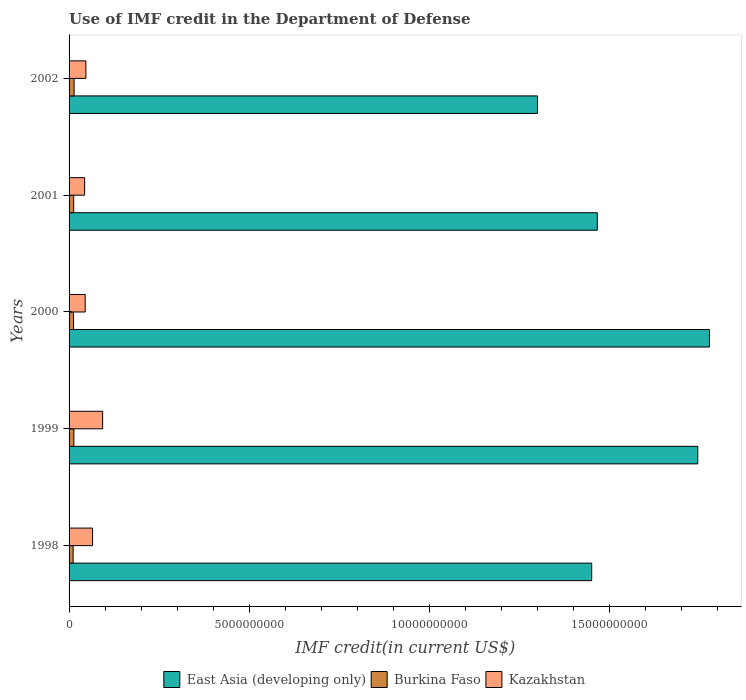How many different coloured bars are there?
Keep it short and to the point. 3. How many groups of bars are there?
Your answer should be very brief. 5. How many bars are there on the 2nd tick from the top?
Your answer should be very brief. 3. How many bars are there on the 5th tick from the bottom?
Make the answer very short. 3. What is the label of the 1st group of bars from the top?
Provide a succinct answer. 2002. What is the IMF credit in the Department of Defense in East Asia (developing only) in 1999?
Your response must be concise. 1.75e+1. Across all years, what is the maximum IMF credit in the Department of Defense in East Asia (developing only)?
Your answer should be compact. 1.78e+1. Across all years, what is the minimum IMF credit in the Department of Defense in Kazakhstan?
Ensure brevity in your answer.  4.32e+08. In which year was the IMF credit in the Department of Defense in East Asia (developing only) maximum?
Provide a short and direct response. 2000. In which year was the IMF credit in the Department of Defense in Kazakhstan minimum?
Your answer should be compact. 2001. What is the total IMF credit in the Department of Defense in East Asia (developing only) in the graph?
Your answer should be very brief. 7.74e+1. What is the difference between the IMF credit in the Department of Defense in Burkina Faso in 1999 and that in 2001?
Offer a very short reply. 5.27e+06. What is the difference between the IMF credit in the Department of Defense in East Asia (developing only) in 1999 and the IMF credit in the Department of Defense in Kazakhstan in 2001?
Offer a very short reply. 1.70e+1. What is the average IMF credit in the Department of Defense in Kazakhstan per year?
Make the answer very short. 5.86e+08. In the year 2002, what is the difference between the IMF credit in the Department of Defense in Burkina Faso and IMF credit in the Department of Defense in East Asia (developing only)?
Provide a succinct answer. -1.29e+1. What is the ratio of the IMF credit in the Department of Defense in East Asia (developing only) in 2001 to that in 2002?
Give a very brief answer. 1.13. Is the IMF credit in the Department of Defense in Burkina Faso in 1998 less than that in 2002?
Offer a very short reply. Yes. Is the difference between the IMF credit in the Department of Defense in Burkina Faso in 1998 and 1999 greater than the difference between the IMF credit in the Department of Defense in East Asia (developing only) in 1998 and 1999?
Give a very brief answer. Yes. What is the difference between the highest and the second highest IMF credit in the Department of Defense in East Asia (developing only)?
Ensure brevity in your answer.  3.25e+08. What is the difference between the highest and the lowest IMF credit in the Department of Defense in Burkina Faso?
Offer a very short reply. 2.72e+07. What does the 2nd bar from the top in 2002 represents?
Offer a very short reply. Burkina Faso. What does the 1st bar from the bottom in 2000 represents?
Offer a terse response. East Asia (developing only). Is it the case that in every year, the sum of the IMF credit in the Department of Defense in East Asia (developing only) and IMF credit in the Department of Defense in Burkina Faso is greater than the IMF credit in the Department of Defense in Kazakhstan?
Make the answer very short. Yes. Are all the bars in the graph horizontal?
Offer a terse response. Yes. How many years are there in the graph?
Offer a very short reply. 5. Are the values on the major ticks of X-axis written in scientific E-notation?
Provide a succinct answer. No. Does the graph contain any zero values?
Your response must be concise. No. Where does the legend appear in the graph?
Your response must be concise. Bottom center. What is the title of the graph?
Your answer should be very brief. Use of IMF credit in the Department of Defense. What is the label or title of the X-axis?
Ensure brevity in your answer.  IMF credit(in current US$). What is the label or title of the Y-axis?
Keep it short and to the point. Years. What is the IMF credit(in current US$) in East Asia (developing only) in 1998?
Your answer should be very brief. 1.45e+1. What is the IMF credit(in current US$) of Burkina Faso in 1998?
Your answer should be very brief. 1.12e+08. What is the IMF credit(in current US$) in Kazakhstan in 1998?
Offer a terse response. 6.53e+08. What is the IMF credit(in current US$) of East Asia (developing only) in 1999?
Give a very brief answer. 1.75e+1. What is the IMF credit(in current US$) of Burkina Faso in 1999?
Provide a short and direct response. 1.34e+08. What is the IMF credit(in current US$) of Kazakhstan in 1999?
Ensure brevity in your answer.  9.32e+08. What is the IMF credit(in current US$) in East Asia (developing only) in 2000?
Your answer should be compact. 1.78e+1. What is the IMF credit(in current US$) in Burkina Faso in 2000?
Offer a very short reply. 1.24e+08. What is the IMF credit(in current US$) of Kazakhstan in 2000?
Provide a succinct answer. 4.48e+08. What is the IMF credit(in current US$) of East Asia (developing only) in 2001?
Your answer should be compact. 1.47e+1. What is the IMF credit(in current US$) in Burkina Faso in 2001?
Provide a succinct answer. 1.28e+08. What is the IMF credit(in current US$) of Kazakhstan in 2001?
Your response must be concise. 4.32e+08. What is the IMF credit(in current US$) of East Asia (developing only) in 2002?
Offer a very short reply. 1.30e+1. What is the IMF credit(in current US$) in Burkina Faso in 2002?
Provide a succinct answer. 1.39e+08. What is the IMF credit(in current US$) in Kazakhstan in 2002?
Make the answer very short. 4.67e+08. Across all years, what is the maximum IMF credit(in current US$) in East Asia (developing only)?
Ensure brevity in your answer.  1.78e+1. Across all years, what is the maximum IMF credit(in current US$) of Burkina Faso?
Your answer should be compact. 1.39e+08. Across all years, what is the maximum IMF credit(in current US$) in Kazakhstan?
Make the answer very short. 9.32e+08. Across all years, what is the minimum IMF credit(in current US$) in East Asia (developing only)?
Keep it short and to the point. 1.30e+1. Across all years, what is the minimum IMF credit(in current US$) in Burkina Faso?
Your answer should be very brief. 1.12e+08. Across all years, what is the minimum IMF credit(in current US$) in Kazakhstan?
Offer a terse response. 4.32e+08. What is the total IMF credit(in current US$) in East Asia (developing only) in the graph?
Provide a short and direct response. 7.74e+1. What is the total IMF credit(in current US$) of Burkina Faso in the graph?
Offer a very short reply. 6.38e+08. What is the total IMF credit(in current US$) of Kazakhstan in the graph?
Provide a short and direct response. 2.93e+09. What is the difference between the IMF credit(in current US$) in East Asia (developing only) in 1998 and that in 1999?
Your answer should be very brief. -2.95e+09. What is the difference between the IMF credit(in current US$) in Burkina Faso in 1998 and that in 1999?
Give a very brief answer. -2.15e+07. What is the difference between the IMF credit(in current US$) in Kazakhstan in 1998 and that in 1999?
Keep it short and to the point. -2.79e+08. What is the difference between the IMF credit(in current US$) of East Asia (developing only) in 1998 and that in 2000?
Offer a very short reply. -3.27e+09. What is the difference between the IMF credit(in current US$) in Burkina Faso in 1998 and that in 2000?
Give a very brief answer. -1.23e+07. What is the difference between the IMF credit(in current US$) of Kazakhstan in 1998 and that in 2000?
Provide a succinct answer. 2.05e+08. What is the difference between the IMF credit(in current US$) in East Asia (developing only) in 1998 and that in 2001?
Offer a terse response. -1.56e+08. What is the difference between the IMF credit(in current US$) in Burkina Faso in 1998 and that in 2001?
Provide a short and direct response. -1.62e+07. What is the difference between the IMF credit(in current US$) of Kazakhstan in 1998 and that in 2001?
Make the answer very short. 2.21e+08. What is the difference between the IMF credit(in current US$) in East Asia (developing only) in 1998 and that in 2002?
Provide a succinct answer. 1.50e+09. What is the difference between the IMF credit(in current US$) of Burkina Faso in 1998 and that in 2002?
Keep it short and to the point. -2.72e+07. What is the difference between the IMF credit(in current US$) of Kazakhstan in 1998 and that in 2002?
Keep it short and to the point. 1.86e+08. What is the difference between the IMF credit(in current US$) of East Asia (developing only) in 1999 and that in 2000?
Ensure brevity in your answer.  -3.25e+08. What is the difference between the IMF credit(in current US$) of Burkina Faso in 1999 and that in 2000?
Keep it short and to the point. 9.20e+06. What is the difference between the IMF credit(in current US$) of Kazakhstan in 1999 and that in 2000?
Offer a very short reply. 4.84e+08. What is the difference between the IMF credit(in current US$) in East Asia (developing only) in 1999 and that in 2001?
Provide a short and direct response. 2.79e+09. What is the difference between the IMF credit(in current US$) of Burkina Faso in 1999 and that in 2001?
Provide a succinct answer. 5.27e+06. What is the difference between the IMF credit(in current US$) in Kazakhstan in 1999 and that in 2001?
Provide a succinct answer. 5.00e+08. What is the difference between the IMF credit(in current US$) in East Asia (developing only) in 1999 and that in 2002?
Provide a succinct answer. 4.45e+09. What is the difference between the IMF credit(in current US$) of Burkina Faso in 1999 and that in 2002?
Offer a very short reply. -5.69e+06. What is the difference between the IMF credit(in current US$) in Kazakhstan in 1999 and that in 2002?
Your answer should be compact. 4.64e+08. What is the difference between the IMF credit(in current US$) of East Asia (developing only) in 2000 and that in 2001?
Ensure brevity in your answer.  3.11e+09. What is the difference between the IMF credit(in current US$) of Burkina Faso in 2000 and that in 2001?
Your response must be concise. -3.93e+06. What is the difference between the IMF credit(in current US$) in Kazakhstan in 2000 and that in 2001?
Provide a short and direct response. 1.59e+07. What is the difference between the IMF credit(in current US$) in East Asia (developing only) in 2000 and that in 2002?
Ensure brevity in your answer.  4.77e+09. What is the difference between the IMF credit(in current US$) of Burkina Faso in 2000 and that in 2002?
Ensure brevity in your answer.  -1.49e+07. What is the difference between the IMF credit(in current US$) in Kazakhstan in 2000 and that in 2002?
Ensure brevity in your answer.  -1.95e+07. What is the difference between the IMF credit(in current US$) of East Asia (developing only) in 2001 and that in 2002?
Make the answer very short. 1.66e+09. What is the difference between the IMF credit(in current US$) of Burkina Faso in 2001 and that in 2002?
Your response must be concise. -1.10e+07. What is the difference between the IMF credit(in current US$) in Kazakhstan in 2001 and that in 2002?
Offer a terse response. -3.53e+07. What is the difference between the IMF credit(in current US$) in East Asia (developing only) in 1998 and the IMF credit(in current US$) in Burkina Faso in 1999?
Your response must be concise. 1.44e+1. What is the difference between the IMF credit(in current US$) in East Asia (developing only) in 1998 and the IMF credit(in current US$) in Kazakhstan in 1999?
Your answer should be very brief. 1.36e+1. What is the difference between the IMF credit(in current US$) of Burkina Faso in 1998 and the IMF credit(in current US$) of Kazakhstan in 1999?
Give a very brief answer. -8.20e+08. What is the difference between the IMF credit(in current US$) of East Asia (developing only) in 1998 and the IMF credit(in current US$) of Burkina Faso in 2000?
Your answer should be very brief. 1.44e+1. What is the difference between the IMF credit(in current US$) of East Asia (developing only) in 1998 and the IMF credit(in current US$) of Kazakhstan in 2000?
Your answer should be compact. 1.41e+1. What is the difference between the IMF credit(in current US$) of Burkina Faso in 1998 and the IMF credit(in current US$) of Kazakhstan in 2000?
Ensure brevity in your answer.  -3.36e+08. What is the difference between the IMF credit(in current US$) in East Asia (developing only) in 1998 and the IMF credit(in current US$) in Burkina Faso in 2001?
Provide a succinct answer. 1.44e+1. What is the difference between the IMF credit(in current US$) of East Asia (developing only) in 1998 and the IMF credit(in current US$) of Kazakhstan in 2001?
Keep it short and to the point. 1.41e+1. What is the difference between the IMF credit(in current US$) of Burkina Faso in 1998 and the IMF credit(in current US$) of Kazakhstan in 2001?
Keep it short and to the point. -3.20e+08. What is the difference between the IMF credit(in current US$) of East Asia (developing only) in 1998 and the IMF credit(in current US$) of Burkina Faso in 2002?
Make the answer very short. 1.44e+1. What is the difference between the IMF credit(in current US$) in East Asia (developing only) in 1998 and the IMF credit(in current US$) in Kazakhstan in 2002?
Make the answer very short. 1.40e+1. What is the difference between the IMF credit(in current US$) of Burkina Faso in 1998 and the IMF credit(in current US$) of Kazakhstan in 2002?
Provide a succinct answer. -3.55e+08. What is the difference between the IMF credit(in current US$) in East Asia (developing only) in 1999 and the IMF credit(in current US$) in Burkina Faso in 2000?
Offer a very short reply. 1.73e+1. What is the difference between the IMF credit(in current US$) in East Asia (developing only) in 1999 and the IMF credit(in current US$) in Kazakhstan in 2000?
Keep it short and to the point. 1.70e+1. What is the difference between the IMF credit(in current US$) of Burkina Faso in 1999 and the IMF credit(in current US$) of Kazakhstan in 2000?
Ensure brevity in your answer.  -3.14e+08. What is the difference between the IMF credit(in current US$) of East Asia (developing only) in 1999 and the IMF credit(in current US$) of Burkina Faso in 2001?
Your response must be concise. 1.73e+1. What is the difference between the IMF credit(in current US$) in East Asia (developing only) in 1999 and the IMF credit(in current US$) in Kazakhstan in 2001?
Your answer should be very brief. 1.70e+1. What is the difference between the IMF credit(in current US$) in Burkina Faso in 1999 and the IMF credit(in current US$) in Kazakhstan in 2001?
Make the answer very short. -2.98e+08. What is the difference between the IMF credit(in current US$) in East Asia (developing only) in 1999 and the IMF credit(in current US$) in Burkina Faso in 2002?
Your answer should be very brief. 1.73e+1. What is the difference between the IMF credit(in current US$) in East Asia (developing only) in 1999 and the IMF credit(in current US$) in Kazakhstan in 2002?
Keep it short and to the point. 1.70e+1. What is the difference between the IMF credit(in current US$) of Burkina Faso in 1999 and the IMF credit(in current US$) of Kazakhstan in 2002?
Your answer should be compact. -3.34e+08. What is the difference between the IMF credit(in current US$) in East Asia (developing only) in 2000 and the IMF credit(in current US$) in Burkina Faso in 2001?
Provide a short and direct response. 1.77e+1. What is the difference between the IMF credit(in current US$) of East Asia (developing only) in 2000 and the IMF credit(in current US$) of Kazakhstan in 2001?
Provide a succinct answer. 1.73e+1. What is the difference between the IMF credit(in current US$) in Burkina Faso in 2000 and the IMF credit(in current US$) in Kazakhstan in 2001?
Provide a succinct answer. -3.07e+08. What is the difference between the IMF credit(in current US$) in East Asia (developing only) in 2000 and the IMF credit(in current US$) in Burkina Faso in 2002?
Ensure brevity in your answer.  1.76e+1. What is the difference between the IMF credit(in current US$) of East Asia (developing only) in 2000 and the IMF credit(in current US$) of Kazakhstan in 2002?
Give a very brief answer. 1.73e+1. What is the difference between the IMF credit(in current US$) in Burkina Faso in 2000 and the IMF credit(in current US$) in Kazakhstan in 2002?
Provide a succinct answer. -3.43e+08. What is the difference between the IMF credit(in current US$) of East Asia (developing only) in 2001 and the IMF credit(in current US$) of Burkina Faso in 2002?
Your response must be concise. 1.45e+1. What is the difference between the IMF credit(in current US$) in East Asia (developing only) in 2001 and the IMF credit(in current US$) in Kazakhstan in 2002?
Ensure brevity in your answer.  1.42e+1. What is the difference between the IMF credit(in current US$) in Burkina Faso in 2001 and the IMF credit(in current US$) in Kazakhstan in 2002?
Give a very brief answer. -3.39e+08. What is the average IMF credit(in current US$) in East Asia (developing only) per year?
Ensure brevity in your answer.  1.55e+1. What is the average IMF credit(in current US$) of Burkina Faso per year?
Your response must be concise. 1.28e+08. What is the average IMF credit(in current US$) of Kazakhstan per year?
Provide a succinct answer. 5.86e+08. In the year 1998, what is the difference between the IMF credit(in current US$) in East Asia (developing only) and IMF credit(in current US$) in Burkina Faso?
Keep it short and to the point. 1.44e+1. In the year 1998, what is the difference between the IMF credit(in current US$) of East Asia (developing only) and IMF credit(in current US$) of Kazakhstan?
Make the answer very short. 1.39e+1. In the year 1998, what is the difference between the IMF credit(in current US$) of Burkina Faso and IMF credit(in current US$) of Kazakhstan?
Offer a very short reply. -5.41e+08. In the year 1999, what is the difference between the IMF credit(in current US$) of East Asia (developing only) and IMF credit(in current US$) of Burkina Faso?
Keep it short and to the point. 1.73e+1. In the year 1999, what is the difference between the IMF credit(in current US$) of East Asia (developing only) and IMF credit(in current US$) of Kazakhstan?
Provide a short and direct response. 1.65e+1. In the year 1999, what is the difference between the IMF credit(in current US$) in Burkina Faso and IMF credit(in current US$) in Kazakhstan?
Your response must be concise. -7.98e+08. In the year 2000, what is the difference between the IMF credit(in current US$) of East Asia (developing only) and IMF credit(in current US$) of Burkina Faso?
Offer a very short reply. 1.77e+1. In the year 2000, what is the difference between the IMF credit(in current US$) of East Asia (developing only) and IMF credit(in current US$) of Kazakhstan?
Provide a succinct answer. 1.73e+1. In the year 2000, what is the difference between the IMF credit(in current US$) in Burkina Faso and IMF credit(in current US$) in Kazakhstan?
Offer a terse response. -3.23e+08. In the year 2001, what is the difference between the IMF credit(in current US$) of East Asia (developing only) and IMF credit(in current US$) of Burkina Faso?
Provide a succinct answer. 1.45e+1. In the year 2001, what is the difference between the IMF credit(in current US$) of East Asia (developing only) and IMF credit(in current US$) of Kazakhstan?
Your response must be concise. 1.42e+1. In the year 2001, what is the difference between the IMF credit(in current US$) in Burkina Faso and IMF credit(in current US$) in Kazakhstan?
Make the answer very short. -3.04e+08. In the year 2002, what is the difference between the IMF credit(in current US$) of East Asia (developing only) and IMF credit(in current US$) of Burkina Faso?
Your response must be concise. 1.29e+1. In the year 2002, what is the difference between the IMF credit(in current US$) of East Asia (developing only) and IMF credit(in current US$) of Kazakhstan?
Ensure brevity in your answer.  1.25e+1. In the year 2002, what is the difference between the IMF credit(in current US$) in Burkina Faso and IMF credit(in current US$) in Kazakhstan?
Keep it short and to the point. -3.28e+08. What is the ratio of the IMF credit(in current US$) in East Asia (developing only) in 1998 to that in 1999?
Your response must be concise. 0.83. What is the ratio of the IMF credit(in current US$) in Burkina Faso in 1998 to that in 1999?
Your answer should be compact. 0.84. What is the ratio of the IMF credit(in current US$) of Kazakhstan in 1998 to that in 1999?
Your answer should be very brief. 0.7. What is the ratio of the IMF credit(in current US$) of East Asia (developing only) in 1998 to that in 2000?
Offer a terse response. 0.82. What is the ratio of the IMF credit(in current US$) in Burkina Faso in 1998 to that in 2000?
Keep it short and to the point. 0.9. What is the ratio of the IMF credit(in current US$) in Kazakhstan in 1998 to that in 2000?
Your answer should be very brief. 1.46. What is the ratio of the IMF credit(in current US$) of East Asia (developing only) in 1998 to that in 2001?
Keep it short and to the point. 0.99. What is the ratio of the IMF credit(in current US$) of Burkina Faso in 1998 to that in 2001?
Offer a very short reply. 0.87. What is the ratio of the IMF credit(in current US$) of Kazakhstan in 1998 to that in 2001?
Make the answer very short. 1.51. What is the ratio of the IMF credit(in current US$) in East Asia (developing only) in 1998 to that in 2002?
Provide a short and direct response. 1.12. What is the ratio of the IMF credit(in current US$) of Burkina Faso in 1998 to that in 2002?
Your answer should be compact. 0.8. What is the ratio of the IMF credit(in current US$) of Kazakhstan in 1998 to that in 2002?
Give a very brief answer. 1.4. What is the ratio of the IMF credit(in current US$) of East Asia (developing only) in 1999 to that in 2000?
Give a very brief answer. 0.98. What is the ratio of the IMF credit(in current US$) of Burkina Faso in 1999 to that in 2000?
Offer a very short reply. 1.07. What is the ratio of the IMF credit(in current US$) in Kazakhstan in 1999 to that in 2000?
Your response must be concise. 2.08. What is the ratio of the IMF credit(in current US$) in East Asia (developing only) in 1999 to that in 2001?
Give a very brief answer. 1.19. What is the ratio of the IMF credit(in current US$) in Burkina Faso in 1999 to that in 2001?
Give a very brief answer. 1.04. What is the ratio of the IMF credit(in current US$) in Kazakhstan in 1999 to that in 2001?
Give a very brief answer. 2.16. What is the ratio of the IMF credit(in current US$) of East Asia (developing only) in 1999 to that in 2002?
Your answer should be compact. 1.34. What is the ratio of the IMF credit(in current US$) in Burkina Faso in 1999 to that in 2002?
Make the answer very short. 0.96. What is the ratio of the IMF credit(in current US$) of Kazakhstan in 1999 to that in 2002?
Give a very brief answer. 1.99. What is the ratio of the IMF credit(in current US$) in East Asia (developing only) in 2000 to that in 2001?
Ensure brevity in your answer.  1.21. What is the ratio of the IMF credit(in current US$) in Burkina Faso in 2000 to that in 2001?
Give a very brief answer. 0.97. What is the ratio of the IMF credit(in current US$) of Kazakhstan in 2000 to that in 2001?
Offer a terse response. 1.04. What is the ratio of the IMF credit(in current US$) in East Asia (developing only) in 2000 to that in 2002?
Your answer should be very brief. 1.37. What is the ratio of the IMF credit(in current US$) of Burkina Faso in 2000 to that in 2002?
Provide a succinct answer. 0.89. What is the ratio of the IMF credit(in current US$) of Kazakhstan in 2000 to that in 2002?
Offer a very short reply. 0.96. What is the ratio of the IMF credit(in current US$) in East Asia (developing only) in 2001 to that in 2002?
Provide a short and direct response. 1.13. What is the ratio of the IMF credit(in current US$) in Burkina Faso in 2001 to that in 2002?
Keep it short and to the point. 0.92. What is the ratio of the IMF credit(in current US$) of Kazakhstan in 2001 to that in 2002?
Your response must be concise. 0.92. What is the difference between the highest and the second highest IMF credit(in current US$) in East Asia (developing only)?
Ensure brevity in your answer.  3.25e+08. What is the difference between the highest and the second highest IMF credit(in current US$) of Burkina Faso?
Provide a succinct answer. 5.69e+06. What is the difference between the highest and the second highest IMF credit(in current US$) in Kazakhstan?
Offer a very short reply. 2.79e+08. What is the difference between the highest and the lowest IMF credit(in current US$) in East Asia (developing only)?
Make the answer very short. 4.77e+09. What is the difference between the highest and the lowest IMF credit(in current US$) in Burkina Faso?
Offer a terse response. 2.72e+07. What is the difference between the highest and the lowest IMF credit(in current US$) in Kazakhstan?
Offer a very short reply. 5.00e+08. 